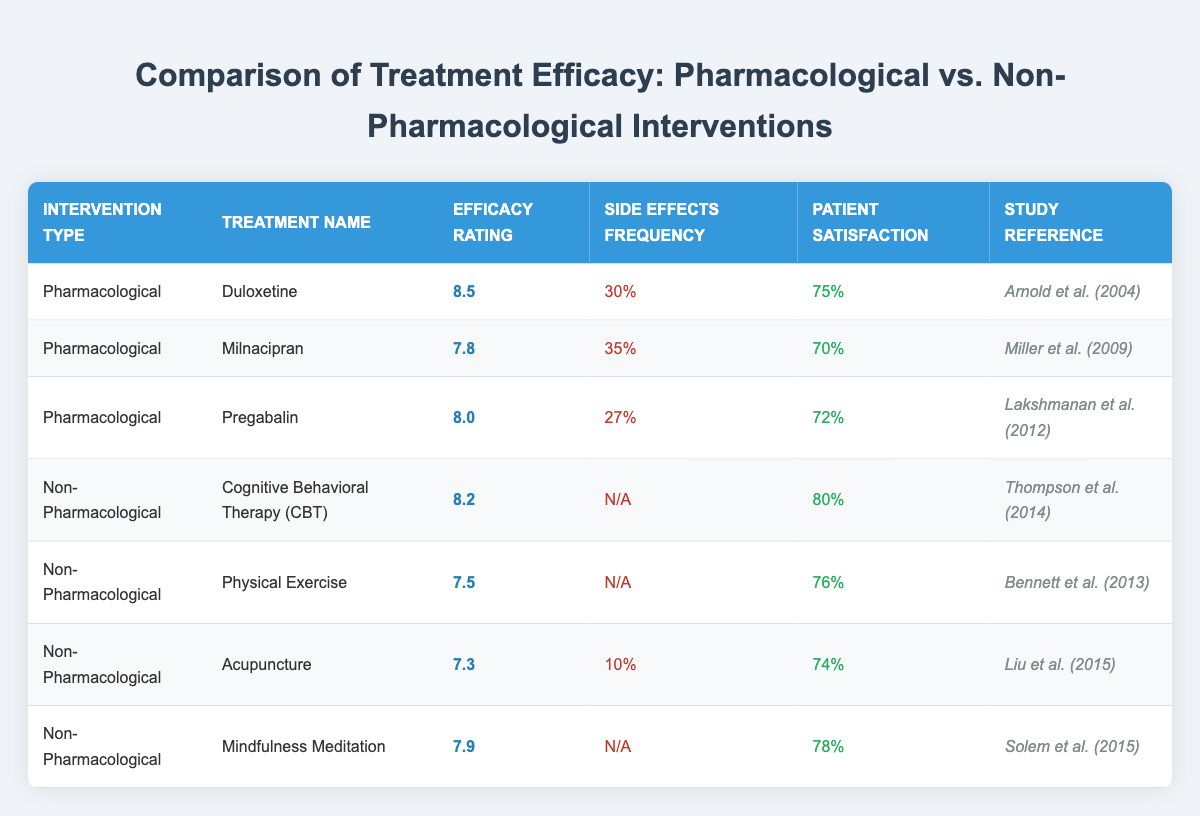What is the efficacy rating of Duloxetine? The efficacy rating of Duloxetine is clearly listed in the table under the "Efficacy Rating" column for the "Pharmacological" intervention type.
Answer: 8.5 Which treatment has the highest patient satisfaction? The "Patient Satisfaction" column shows that Cognitive Behavioral Therapy (CBT) has the highest rate at 80%, compared to other treatments listed in the table.
Answer: Cognitive Behavioral Therapy (CBT) What is the side effects frequency of Acupuncture? In the "Side Effects Frequency" column for Acupuncture, it is stated as 10%.
Answer: 10% What is the average efficacy rating of Non-Pharmacological treatments? To calculate the average: (8.2 + 7.5 + 7.3 + 7.9) = 30.9, then divide by 4 (number of treatments) to get 30.9/4 = 7.725.
Answer: 7.725 Which pharmacological treatment has the lowest side effects frequency? By comparing the "Side Effects Frequency" among the pharmacological treatments, Pregabalin has the lowest at 27%.
Answer: Pregabalin Is it true that Physical Exercise has a higher efficacy rating than Acupuncture? The efficacy rating for Physical Exercise is 7.5 and for Acupuncture, it is 7.3. Since 7.5 > 7.3, the statement is true.
Answer: True What is the difference in patient satisfaction between CBT and Milnacipran? The patient satisfaction for CBT is 80% and for Milnacipran it is 70%. The difference is 80% - 70% = 10%.
Answer: 10% How many treatments listed have an efficacy rating above 8? From the table, both Duloxetine (8.5) and CBT (8.2) have ratings above 8. Thus, there are 2 treatments.
Answer: 2 What treatment has the highest efficacy rating and what type is it? Duloxetine has the highest efficacy rating at 8.5, and it is classified as a Pharmacological treatment.
Answer: Duloxetine, Pharmacological Is the side effects frequency for Mindfulness Meditation available? The table indicates "N/A" for the side effects frequency of Mindfulness Meditation, meaning there is no data available.
Answer: No 